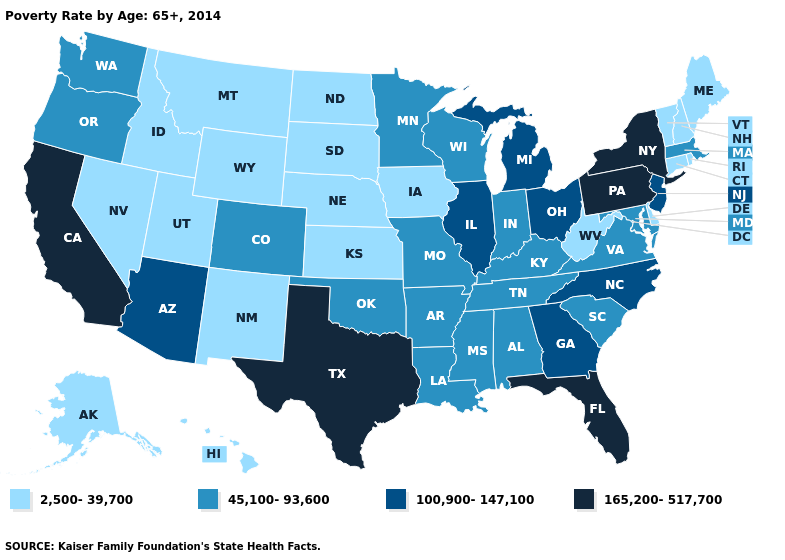Name the states that have a value in the range 100,900-147,100?
Quick response, please. Arizona, Georgia, Illinois, Michigan, New Jersey, North Carolina, Ohio. Does Washington have the highest value in the West?
Give a very brief answer. No. How many symbols are there in the legend?
Quick response, please. 4. Name the states that have a value in the range 100,900-147,100?
Answer briefly. Arizona, Georgia, Illinois, Michigan, New Jersey, North Carolina, Ohio. Which states have the lowest value in the MidWest?
Give a very brief answer. Iowa, Kansas, Nebraska, North Dakota, South Dakota. Does Missouri have the highest value in the MidWest?
Answer briefly. No. How many symbols are there in the legend?
Write a very short answer. 4. What is the lowest value in the MidWest?
Write a very short answer. 2,500-39,700. What is the value of West Virginia?
Short answer required. 2,500-39,700. Name the states that have a value in the range 100,900-147,100?
Concise answer only. Arizona, Georgia, Illinois, Michigan, New Jersey, North Carolina, Ohio. What is the value of Maryland?
Write a very short answer. 45,100-93,600. Does the map have missing data?
Write a very short answer. No. Among the states that border South Carolina , which have the lowest value?
Concise answer only. Georgia, North Carolina. Which states have the lowest value in the USA?
Concise answer only. Alaska, Connecticut, Delaware, Hawaii, Idaho, Iowa, Kansas, Maine, Montana, Nebraska, Nevada, New Hampshire, New Mexico, North Dakota, Rhode Island, South Dakota, Utah, Vermont, West Virginia, Wyoming. Does Nebraska have the highest value in the MidWest?
Answer briefly. No. 